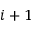Convert formula to latex. <formula><loc_0><loc_0><loc_500><loc_500>i + 1</formula> 